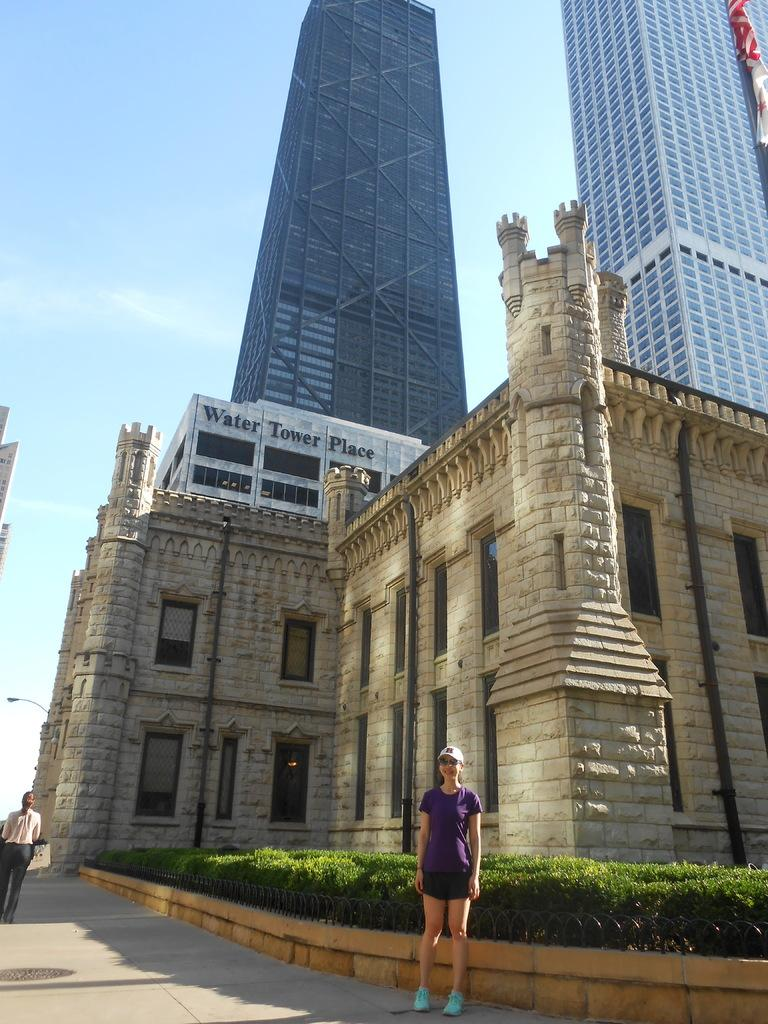How many people are present in the image? There are two persons in the image. What else can be seen in the image besides the people? There are plants, buildings, a board, and a flag visible in the image. What is the background of the image? The sky is visible in the background of the image. What type of nut is being used to write on the board in the image? There is no nut present in the image, and the board does not show any writing. Can you tell me how many pens are visible in the image? There is no pen present in the image. 